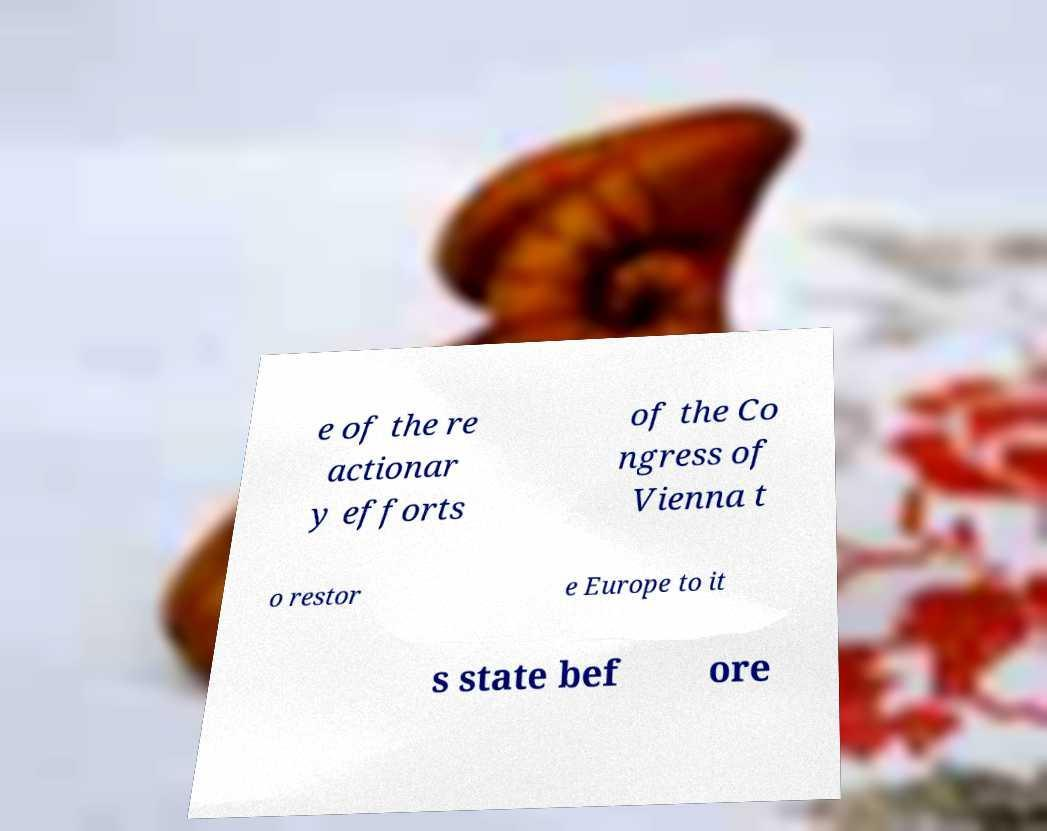What messages or text are displayed in this image? I need them in a readable, typed format. e of the re actionar y efforts of the Co ngress of Vienna t o restor e Europe to it s state bef ore 